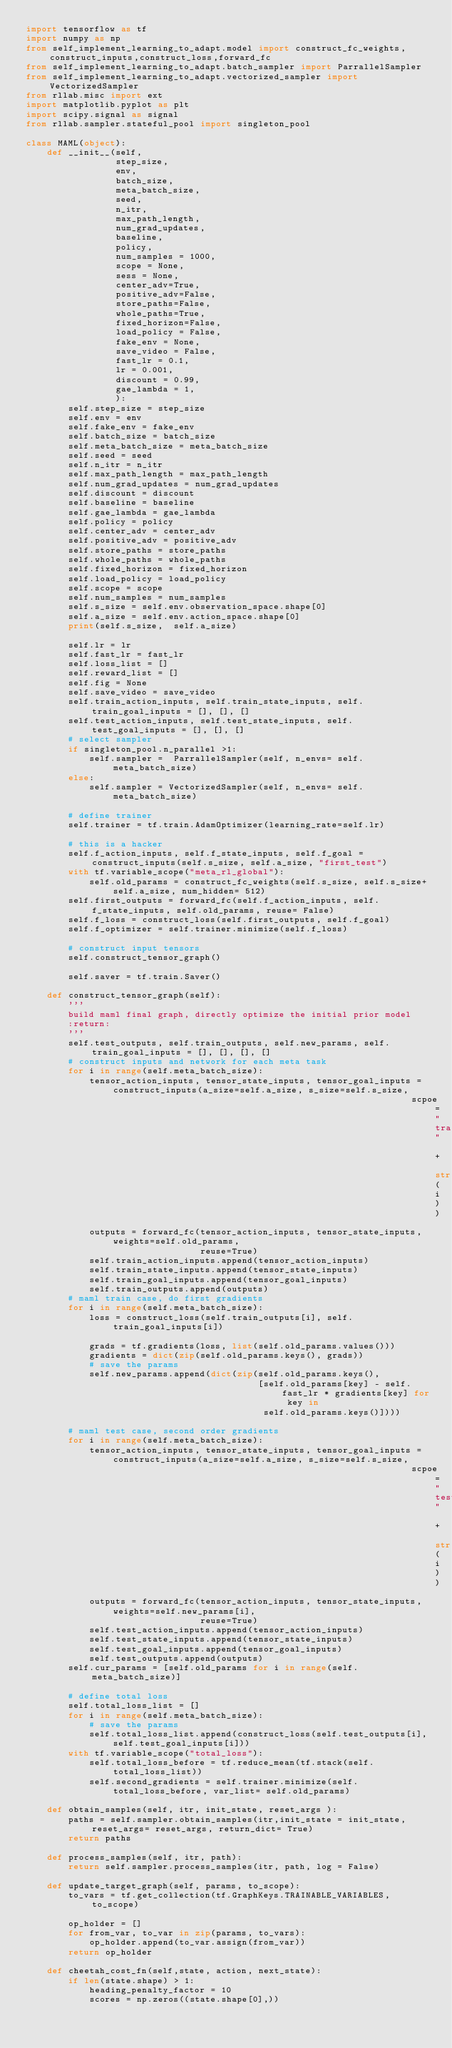Convert code to text. <code><loc_0><loc_0><loc_500><loc_500><_Python_>import tensorflow as tf
import numpy as np
from self_implement_learning_to_adapt.model import construct_fc_weights,construct_inputs,construct_loss,forward_fc
from self_implement_learning_to_adapt.batch_sampler import ParrallelSampler
from self_implement_learning_to_adapt.vectorized_sampler import VectorizedSampler
from rllab.misc import ext
import matplotlib.pyplot as plt
import scipy.signal as signal
from rllab.sampler.stateful_pool import singleton_pool

class MAML(object):
    def __init__(self,
                 step_size,
                 env,
                 batch_size,
                 meta_batch_size,
                 seed,
                 n_itr,
                 max_path_length,
                 num_grad_updates,
                 baseline,
                 policy,
                 num_samples = 1000,
                 scope = None,
                 sess = None,
                 center_adv=True,
                 positive_adv=False,
                 store_paths=False,
                 whole_paths=True,
                 fixed_horizon=False,
                 load_policy = False,
                 fake_env = None,
                 save_video = False,
                 fast_lr = 0.1,
                 lr = 0.001,
                 discount = 0.99,
                 gae_lambda = 1,
                 ):
        self.step_size = step_size
        self.env = env
        self.fake_env = fake_env
        self.batch_size = batch_size
        self.meta_batch_size = meta_batch_size
        self.seed = seed
        self.n_itr = n_itr
        self.max_path_length = max_path_length
        self.num_grad_updates = num_grad_updates
        self.discount = discount
        self.baseline = baseline
        self.gae_lambda = gae_lambda
        self.policy = policy
        self.center_adv = center_adv
        self.positive_adv = positive_adv
        self.store_paths = store_paths
        self.whole_paths = whole_paths
        self.fixed_horizon = fixed_horizon
        self.load_policy = load_policy
        self.scope = scope
        self.num_samples = num_samples
        self.s_size = self.env.observation_space.shape[0]
        self.a_size = self.env.action_space.shape[0]
        print(self.s_size,  self.a_size)

        self.lr = lr
        self.fast_lr = fast_lr
        self.loss_list = []
        self.reward_list = []
        self.fig = None
        self.save_video = save_video
        self.train_action_inputs, self.train_state_inputs, self.train_goal_inputs = [], [], []
        self.test_action_inputs, self.test_state_inputs, self.test_goal_inputs = [], [], []
        # select sampler
        if singleton_pool.n_parallel >1:
            self.sampler =  ParrallelSampler(self, n_envs= self.meta_batch_size)
        else:
            self.sampler = VectorizedSampler(self, n_envs= self.meta_batch_size)

        # define trainer
        self.trainer = tf.train.AdamOptimizer(learning_rate=self.lr)

        # this is a hacker
        self.f_action_inputs, self.f_state_inputs, self.f_goal = construct_inputs(self.s_size, self.a_size, "first_test")
        with tf.variable_scope("meta_rl_global"):
            self.old_params = construct_fc_weights(self.s_size, self.s_size+ self.a_size, num_hidden= 512)
        self.first_outputs = forward_fc(self.f_action_inputs, self.f_state_inputs, self.old_params, reuse= False)
        self.f_loss = construct_loss(self.first_outputs, self.f_goal)
        self.f_optimizer = self.trainer.minimize(self.f_loss)

        # construct input tensors
        self.construct_tensor_graph()

        self.saver = tf.train.Saver()

    def construct_tensor_graph(self):
        '''
        build maml final graph, directly optimize the initial prior model
        :return:
        '''
        self.test_outputs, self.train_outputs, self.new_params, self.train_goal_inputs = [], [], [], []
        # construct inputs and network for each meta task
        for i in range(self.meta_batch_size):
            tensor_action_inputs, tensor_state_inputs, tensor_goal_inputs = construct_inputs(a_size=self.a_size, s_size=self.s_size,
                                                                         scpoe="train_inputs" + str(i))
            outputs = forward_fc(tensor_action_inputs, tensor_state_inputs, weights=self.old_params,
                                 reuse=True)
            self.train_action_inputs.append(tensor_action_inputs)
            self.train_state_inputs.append(tensor_state_inputs)
            self.train_goal_inputs.append(tensor_goal_inputs)
            self.train_outputs.append(outputs)
        # maml train case, do first gradients
        for i in range(self.meta_batch_size):
            loss = construct_loss(self.train_outputs[i], self.train_goal_inputs[i])

            grads = tf.gradients(loss, list(self.old_params.values()))
            gradients = dict(zip(self.old_params.keys(), grads))
            # save the params
            self.new_params.append(dict(zip(self.old_params.keys(),
                                            [self.old_params[key] - self.fast_lr * gradients[key] for key in
                                             self.old_params.keys()])))

        # maml test case, second order gradients
        for i in range(self.meta_batch_size):
            tensor_action_inputs, tensor_state_inputs, tensor_goal_inputs = construct_inputs(a_size=self.a_size, s_size=self.s_size,
                                                                         scpoe="test_inputs" + str(i))
            outputs = forward_fc(tensor_action_inputs, tensor_state_inputs, weights=self.new_params[i],
                                 reuse=True)
            self.test_action_inputs.append(tensor_action_inputs)
            self.test_state_inputs.append(tensor_state_inputs)
            self.test_goal_inputs.append(tensor_goal_inputs)
            self.test_outputs.append(outputs)
        self.cur_params = [self.old_params for i in range(self.meta_batch_size)]

        # define total loss
        self.total_loss_list = []
        for i in range(self.meta_batch_size):
            # save the params
            self.total_loss_list.append(construct_loss(self.test_outputs[i], self.test_goal_inputs[i]))
        with tf.variable_scope("total_loss"):
            self.total_loss_before = tf.reduce_mean(tf.stack(self.total_loss_list))
            self.second_gradients = self.trainer.minimize(self.total_loss_before, var_list= self.old_params)

    def obtain_samples(self, itr, init_state, reset_args ):
        paths = self.sampler.obtain_samples(itr,init_state = init_state,reset_args= reset_args, return_dict= True)
        return paths

    def process_samples(self, itr, path):
        return self.sampler.process_samples(itr, path, log = False)

    def update_target_graph(self, params, to_scope):
        to_vars = tf.get_collection(tf.GraphKeys.TRAINABLE_VARIABLES, to_scope)

        op_holder = []
        for from_var, to_var in zip(params, to_vars):
            op_holder.append(to_var.assign(from_var))
        return op_holder

    def cheetah_cost_fn(self,state, action, next_state):
        if len(state.shape) > 1:
            heading_penalty_factor = 10
            scores = np.zeros((state.shape[0],))
</code> 